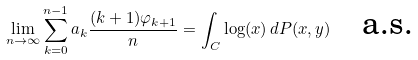Convert formula to latex. <formula><loc_0><loc_0><loc_500><loc_500>\lim _ { n \rightarrow \infty } \sum _ { k = 0 } ^ { n - 1 } a _ { k } \frac { ( k + 1 ) \varphi _ { k + 1 } } { n } = \int _ { C } \log ( x ) \, d P ( x , y ) \quad \text {a.s.}</formula> 